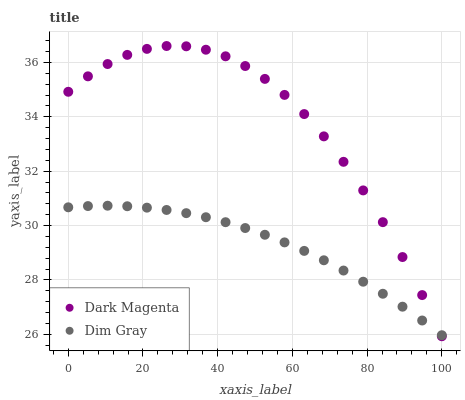Does Dim Gray have the minimum area under the curve?
Answer yes or no. Yes. Does Dark Magenta have the maximum area under the curve?
Answer yes or no. Yes. Does Dark Magenta have the minimum area under the curve?
Answer yes or no. No. Is Dim Gray the smoothest?
Answer yes or no. Yes. Is Dark Magenta the roughest?
Answer yes or no. Yes. Is Dark Magenta the smoothest?
Answer yes or no. No. Does Dark Magenta have the lowest value?
Answer yes or no. Yes. Does Dark Magenta have the highest value?
Answer yes or no. Yes. Does Dim Gray intersect Dark Magenta?
Answer yes or no. Yes. Is Dim Gray less than Dark Magenta?
Answer yes or no. No. Is Dim Gray greater than Dark Magenta?
Answer yes or no. No. 